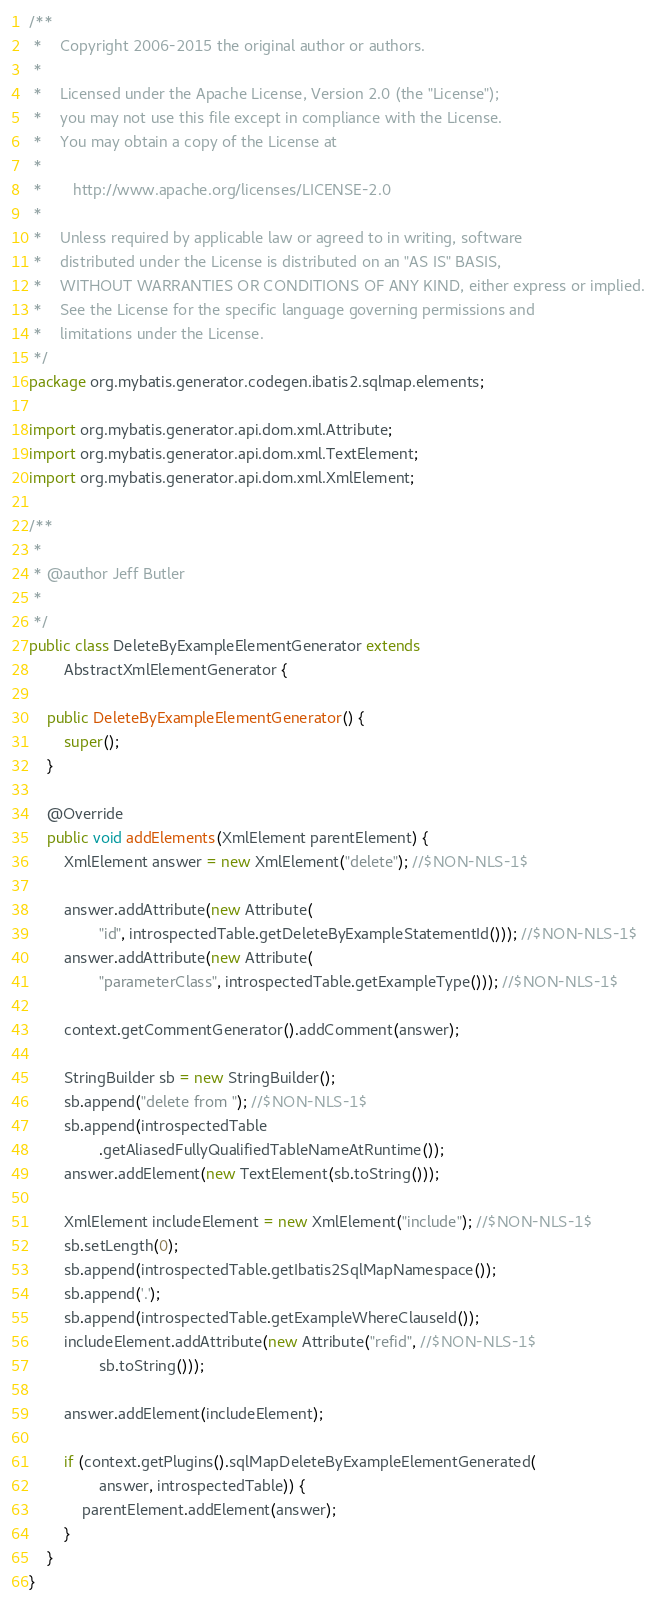Convert code to text. <code><loc_0><loc_0><loc_500><loc_500><_Java_>/**
 *    Copyright 2006-2015 the original author or authors.
 *
 *    Licensed under the Apache License, Version 2.0 (the "License");
 *    you may not use this file except in compliance with the License.
 *    You may obtain a copy of the License at
 *
 *       http://www.apache.org/licenses/LICENSE-2.0
 *
 *    Unless required by applicable law or agreed to in writing, software
 *    distributed under the License is distributed on an "AS IS" BASIS,
 *    WITHOUT WARRANTIES OR CONDITIONS OF ANY KIND, either express or implied.
 *    See the License for the specific language governing permissions and
 *    limitations under the License.
 */
package org.mybatis.generator.codegen.ibatis2.sqlmap.elements;

import org.mybatis.generator.api.dom.xml.Attribute;
import org.mybatis.generator.api.dom.xml.TextElement;
import org.mybatis.generator.api.dom.xml.XmlElement;

/**
 * 
 * @author Jeff Butler
 * 
 */
public class DeleteByExampleElementGenerator extends
        AbstractXmlElementGenerator {

    public DeleteByExampleElementGenerator() {
        super();
    }

    @Override
    public void addElements(XmlElement parentElement) {
        XmlElement answer = new XmlElement("delete"); //$NON-NLS-1$

        answer.addAttribute(new Attribute(
                "id", introspectedTable.getDeleteByExampleStatementId())); //$NON-NLS-1$
        answer.addAttribute(new Attribute(
                "parameterClass", introspectedTable.getExampleType())); //$NON-NLS-1$

        context.getCommentGenerator().addComment(answer);

        StringBuilder sb = new StringBuilder();
        sb.append("delete from "); //$NON-NLS-1$
        sb.append(introspectedTable
                .getAliasedFullyQualifiedTableNameAtRuntime());
        answer.addElement(new TextElement(sb.toString()));

        XmlElement includeElement = new XmlElement("include"); //$NON-NLS-1$
        sb.setLength(0);
        sb.append(introspectedTable.getIbatis2SqlMapNamespace());
        sb.append('.');
        sb.append(introspectedTable.getExampleWhereClauseId());
        includeElement.addAttribute(new Attribute("refid", //$NON-NLS-1$
                sb.toString()));

        answer.addElement(includeElement);

        if (context.getPlugins().sqlMapDeleteByExampleElementGenerated(
                answer, introspectedTable)) {
            parentElement.addElement(answer);
        }
    }
}
</code> 